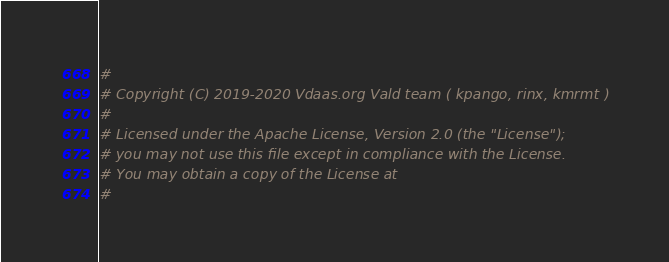Convert code to text. <code><loc_0><loc_0><loc_500><loc_500><_Dockerfile_>#
# Copyright (C) 2019-2020 Vdaas.org Vald team ( kpango, rinx, kmrmt )
#
# Licensed under the Apache License, Version 2.0 (the "License");
# you may not use this file except in compliance with the License.
# You may obtain a copy of the License at
#</code> 